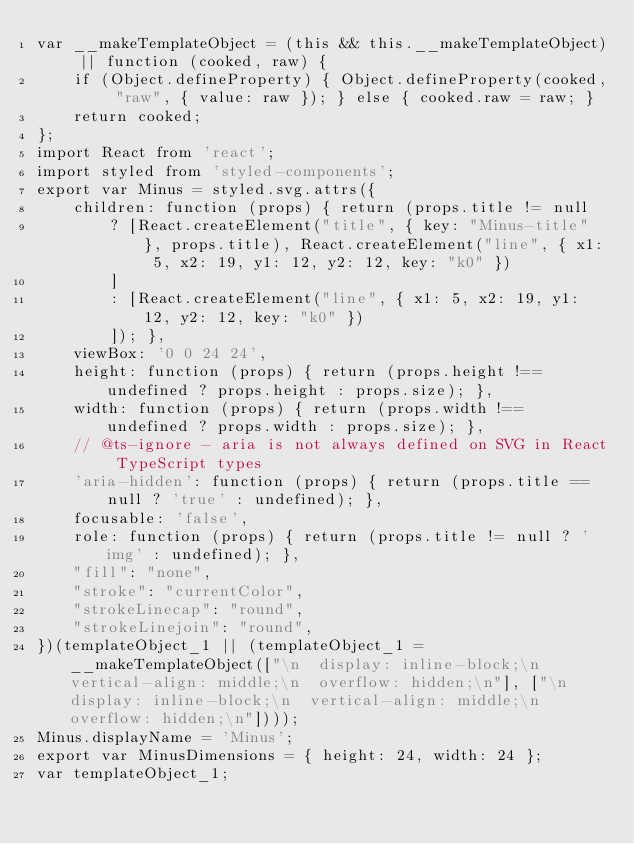Convert code to text. <code><loc_0><loc_0><loc_500><loc_500><_JavaScript_>var __makeTemplateObject = (this && this.__makeTemplateObject) || function (cooked, raw) {
    if (Object.defineProperty) { Object.defineProperty(cooked, "raw", { value: raw }); } else { cooked.raw = raw; }
    return cooked;
};
import React from 'react';
import styled from 'styled-components';
export var Minus = styled.svg.attrs({
    children: function (props) { return (props.title != null
        ? [React.createElement("title", { key: "Minus-title" }, props.title), React.createElement("line", { x1: 5, x2: 19, y1: 12, y2: 12, key: "k0" })
        ]
        : [React.createElement("line", { x1: 5, x2: 19, y1: 12, y2: 12, key: "k0" })
        ]); },
    viewBox: '0 0 24 24',
    height: function (props) { return (props.height !== undefined ? props.height : props.size); },
    width: function (props) { return (props.width !== undefined ? props.width : props.size); },
    // @ts-ignore - aria is not always defined on SVG in React TypeScript types
    'aria-hidden': function (props) { return (props.title == null ? 'true' : undefined); },
    focusable: 'false',
    role: function (props) { return (props.title != null ? 'img' : undefined); },
    "fill": "none",
    "stroke": "currentColor",
    "strokeLinecap": "round",
    "strokeLinejoin": "round",
})(templateObject_1 || (templateObject_1 = __makeTemplateObject(["\n  display: inline-block;\n  vertical-align: middle;\n  overflow: hidden;\n"], ["\n  display: inline-block;\n  vertical-align: middle;\n  overflow: hidden;\n"])));
Minus.displayName = 'Minus';
export var MinusDimensions = { height: 24, width: 24 };
var templateObject_1;
</code> 